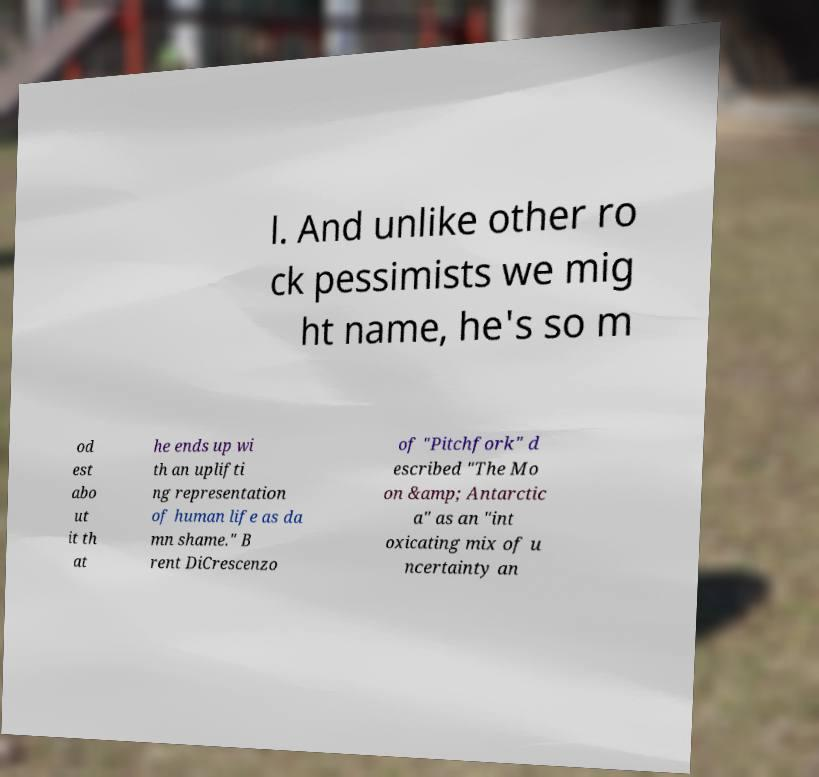For documentation purposes, I need the text within this image transcribed. Could you provide that? l. And unlike other ro ck pessimists we mig ht name, he's so m od est abo ut it th at he ends up wi th an uplifti ng representation of human life as da mn shame." B rent DiCrescenzo of "Pitchfork" d escribed "The Mo on &amp; Antarctic a" as an "int oxicating mix of u ncertainty an 